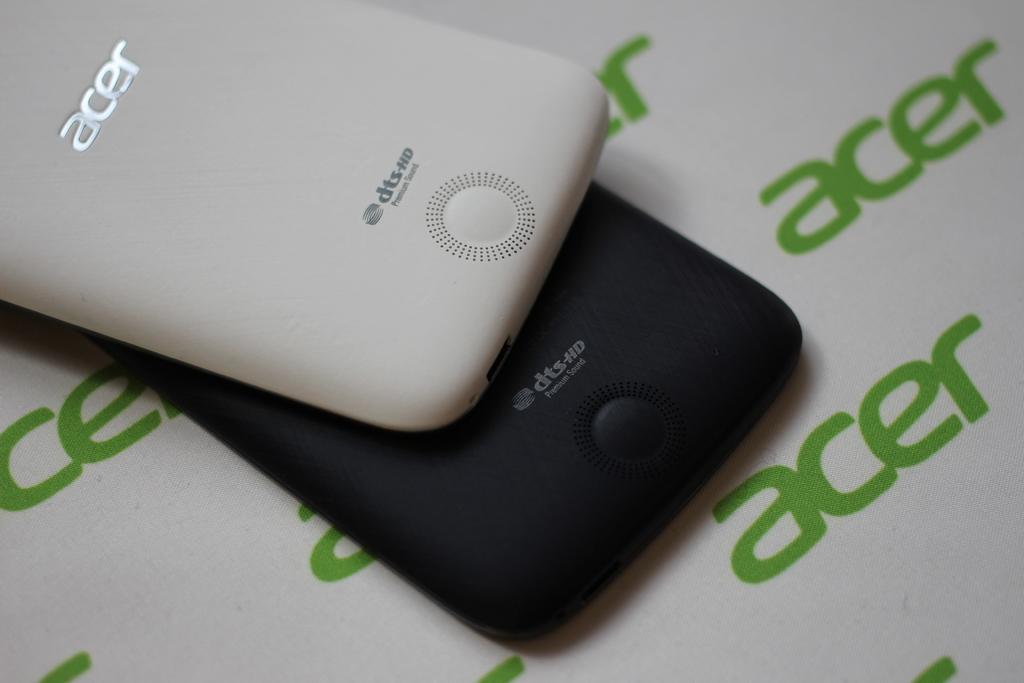What manufacturer is shown here?
Keep it short and to the point. Acer. Is this an acer device?
Provide a succinct answer. Yes. 